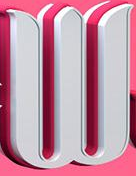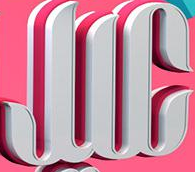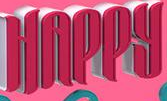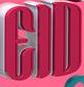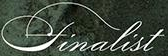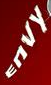Read the text from these images in sequence, separated by a semicolon. W; JIC; HAPPY; EID; finalist; ENVY 